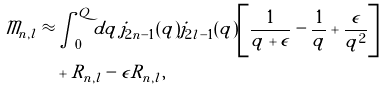Convert formula to latex. <formula><loc_0><loc_0><loc_500><loc_500>\mathcal { M } _ { n , l } \approx & \int _ { 0 } ^ { Q } d q \, j _ { 2 n - 1 } ( q ) j _ { 2 l - 1 } ( q ) \left [ \frac { 1 } { q + \epsilon } - \frac { 1 } { q } + \frac { \epsilon } { q ^ { 2 } } \right ] \\ & + R _ { n , l } - \epsilon \tilde { R } _ { n , l } ,</formula> 